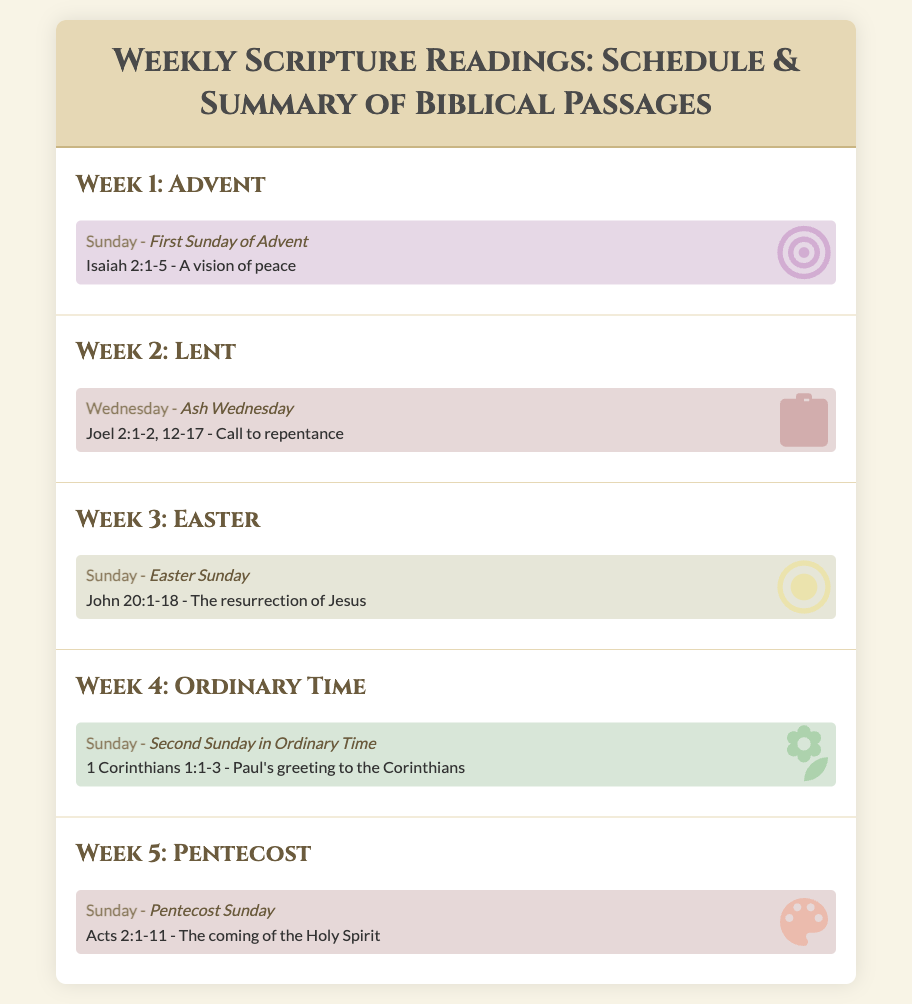What is the title of the document? The title is displayed prominently at the top of the document, providing a clear overview of the content.
Answer: Weekly Scripture Readings: Schedule & Summary of Biblical Passages What scripture passage is read on the First Sunday of Advent? The scripture passage is specifically mentioned under the Advent section for that particular day.
Answer: Isaiah 2:1-5 Which week includes Ash Wednesday readings? The week labeled with a specific title contains information about Ash Wednesday, focusing on its readings.
Answer: Week 2: Lent What biblical event is celebrated on Easter Sunday? The document summarizes the key event that takes place during the Easter Sunday reading.
Answer: The resurrection of Jesus How many readings are listed for Pentecost Sunday? The document details each reading for the week and this specific Sunday, indicating the number of readings.
Answer: One What color theme is used for Ordinary Time? Each week has a background color representing its theme, and Ordinary Time has its own distinctive color mentioned.
Answer: Light green 